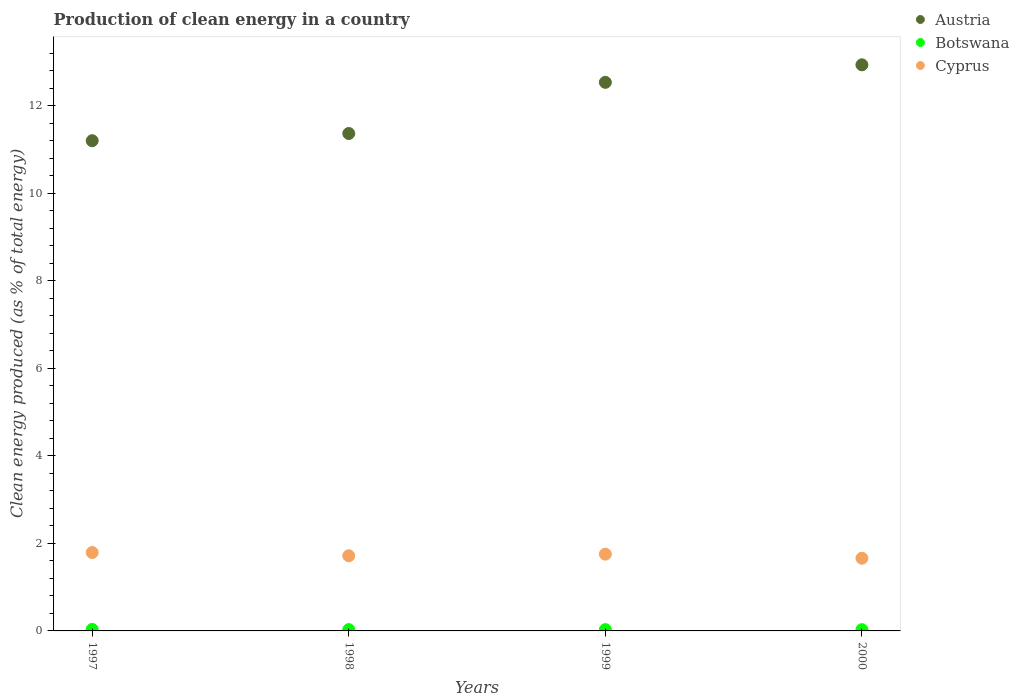How many different coloured dotlines are there?
Give a very brief answer. 3. What is the percentage of clean energy produced in Cyprus in 2000?
Offer a terse response. 1.66. Across all years, what is the maximum percentage of clean energy produced in Austria?
Keep it short and to the point. 12.93. Across all years, what is the minimum percentage of clean energy produced in Cyprus?
Your answer should be very brief. 1.66. In which year was the percentage of clean energy produced in Cyprus minimum?
Make the answer very short. 2000. What is the total percentage of clean energy produced in Botswana in the graph?
Your response must be concise. 0.12. What is the difference between the percentage of clean energy produced in Cyprus in 1998 and that in 2000?
Your answer should be compact. 0.06. What is the difference between the percentage of clean energy produced in Cyprus in 1998 and the percentage of clean energy produced in Austria in 2000?
Offer a terse response. -11.22. What is the average percentage of clean energy produced in Cyprus per year?
Your answer should be very brief. 1.73. In the year 1997, what is the difference between the percentage of clean energy produced in Botswana and percentage of clean energy produced in Austria?
Give a very brief answer. -11.17. In how many years, is the percentage of clean energy produced in Austria greater than 9.2 %?
Give a very brief answer. 4. What is the ratio of the percentage of clean energy produced in Cyprus in 1997 to that in 2000?
Offer a very short reply. 1.08. Is the percentage of clean energy produced in Botswana in 1997 less than that in 2000?
Offer a very short reply. No. Is the difference between the percentage of clean energy produced in Botswana in 1999 and 2000 greater than the difference between the percentage of clean energy produced in Austria in 1999 and 2000?
Your answer should be compact. Yes. What is the difference between the highest and the second highest percentage of clean energy produced in Botswana?
Provide a succinct answer. 0. What is the difference between the highest and the lowest percentage of clean energy produced in Cyprus?
Your answer should be compact. 0.13. Is the sum of the percentage of clean energy produced in Austria in 1998 and 2000 greater than the maximum percentage of clean energy produced in Botswana across all years?
Your response must be concise. Yes. Is it the case that in every year, the sum of the percentage of clean energy produced in Botswana and percentage of clean energy produced in Cyprus  is greater than the percentage of clean energy produced in Austria?
Your answer should be very brief. No. How many years are there in the graph?
Make the answer very short. 4. Where does the legend appear in the graph?
Provide a short and direct response. Top right. How are the legend labels stacked?
Make the answer very short. Vertical. What is the title of the graph?
Ensure brevity in your answer.  Production of clean energy in a country. Does "Niger" appear as one of the legend labels in the graph?
Your answer should be very brief. No. What is the label or title of the X-axis?
Your answer should be compact. Years. What is the label or title of the Y-axis?
Ensure brevity in your answer.  Clean energy produced (as % of total energy). What is the Clean energy produced (as % of total energy) in Austria in 1997?
Provide a succinct answer. 11.2. What is the Clean energy produced (as % of total energy) of Botswana in 1997?
Provide a short and direct response. 0.03. What is the Clean energy produced (as % of total energy) in Cyprus in 1997?
Offer a very short reply. 1.79. What is the Clean energy produced (as % of total energy) in Austria in 1998?
Provide a succinct answer. 11.36. What is the Clean energy produced (as % of total energy) in Botswana in 1998?
Provide a short and direct response. 0.03. What is the Clean energy produced (as % of total energy) in Cyprus in 1998?
Make the answer very short. 1.72. What is the Clean energy produced (as % of total energy) in Austria in 1999?
Your response must be concise. 12.53. What is the Clean energy produced (as % of total energy) in Botswana in 1999?
Keep it short and to the point. 0.03. What is the Clean energy produced (as % of total energy) in Cyprus in 1999?
Offer a terse response. 1.75. What is the Clean energy produced (as % of total energy) of Austria in 2000?
Give a very brief answer. 12.93. What is the Clean energy produced (as % of total energy) in Botswana in 2000?
Your response must be concise. 0.03. What is the Clean energy produced (as % of total energy) in Cyprus in 2000?
Ensure brevity in your answer.  1.66. Across all years, what is the maximum Clean energy produced (as % of total energy) of Austria?
Offer a very short reply. 12.93. Across all years, what is the maximum Clean energy produced (as % of total energy) of Botswana?
Provide a succinct answer. 0.03. Across all years, what is the maximum Clean energy produced (as % of total energy) of Cyprus?
Keep it short and to the point. 1.79. Across all years, what is the minimum Clean energy produced (as % of total energy) in Austria?
Your answer should be very brief. 11.2. Across all years, what is the minimum Clean energy produced (as % of total energy) in Botswana?
Keep it short and to the point. 0.03. Across all years, what is the minimum Clean energy produced (as % of total energy) of Cyprus?
Ensure brevity in your answer.  1.66. What is the total Clean energy produced (as % of total energy) of Austria in the graph?
Offer a very short reply. 48.03. What is the total Clean energy produced (as % of total energy) of Botswana in the graph?
Provide a succinct answer. 0.12. What is the total Clean energy produced (as % of total energy) in Cyprus in the graph?
Your response must be concise. 6.92. What is the difference between the Clean energy produced (as % of total energy) of Austria in 1997 and that in 1998?
Ensure brevity in your answer.  -0.16. What is the difference between the Clean energy produced (as % of total energy) in Botswana in 1997 and that in 1998?
Your response must be concise. 0. What is the difference between the Clean energy produced (as % of total energy) of Cyprus in 1997 and that in 1998?
Offer a terse response. 0.07. What is the difference between the Clean energy produced (as % of total energy) in Austria in 1997 and that in 1999?
Provide a short and direct response. -1.33. What is the difference between the Clean energy produced (as % of total energy) in Botswana in 1997 and that in 1999?
Keep it short and to the point. 0. What is the difference between the Clean energy produced (as % of total energy) in Cyprus in 1997 and that in 1999?
Your answer should be compact. 0.04. What is the difference between the Clean energy produced (as % of total energy) in Austria in 1997 and that in 2000?
Ensure brevity in your answer.  -1.73. What is the difference between the Clean energy produced (as % of total energy) in Botswana in 1997 and that in 2000?
Provide a succinct answer. 0.01. What is the difference between the Clean energy produced (as % of total energy) of Cyprus in 1997 and that in 2000?
Offer a very short reply. 0.13. What is the difference between the Clean energy produced (as % of total energy) of Austria in 1998 and that in 1999?
Offer a terse response. -1.17. What is the difference between the Clean energy produced (as % of total energy) in Botswana in 1998 and that in 1999?
Provide a succinct answer. 0. What is the difference between the Clean energy produced (as % of total energy) of Cyprus in 1998 and that in 1999?
Provide a short and direct response. -0.04. What is the difference between the Clean energy produced (as % of total energy) of Austria in 1998 and that in 2000?
Your answer should be very brief. -1.57. What is the difference between the Clean energy produced (as % of total energy) of Botswana in 1998 and that in 2000?
Offer a terse response. 0. What is the difference between the Clean energy produced (as % of total energy) in Cyprus in 1998 and that in 2000?
Provide a short and direct response. 0.06. What is the difference between the Clean energy produced (as % of total energy) in Austria in 1999 and that in 2000?
Offer a terse response. -0.4. What is the difference between the Clean energy produced (as % of total energy) of Botswana in 1999 and that in 2000?
Offer a very short reply. 0. What is the difference between the Clean energy produced (as % of total energy) in Cyprus in 1999 and that in 2000?
Keep it short and to the point. 0.09. What is the difference between the Clean energy produced (as % of total energy) in Austria in 1997 and the Clean energy produced (as % of total energy) in Botswana in 1998?
Offer a terse response. 11.17. What is the difference between the Clean energy produced (as % of total energy) in Austria in 1997 and the Clean energy produced (as % of total energy) in Cyprus in 1998?
Your response must be concise. 9.48. What is the difference between the Clean energy produced (as % of total energy) of Botswana in 1997 and the Clean energy produced (as % of total energy) of Cyprus in 1998?
Provide a short and direct response. -1.68. What is the difference between the Clean energy produced (as % of total energy) in Austria in 1997 and the Clean energy produced (as % of total energy) in Botswana in 1999?
Offer a very short reply. 11.17. What is the difference between the Clean energy produced (as % of total energy) of Austria in 1997 and the Clean energy produced (as % of total energy) of Cyprus in 1999?
Give a very brief answer. 9.45. What is the difference between the Clean energy produced (as % of total energy) of Botswana in 1997 and the Clean energy produced (as % of total energy) of Cyprus in 1999?
Give a very brief answer. -1.72. What is the difference between the Clean energy produced (as % of total energy) of Austria in 1997 and the Clean energy produced (as % of total energy) of Botswana in 2000?
Offer a very short reply. 11.17. What is the difference between the Clean energy produced (as % of total energy) in Austria in 1997 and the Clean energy produced (as % of total energy) in Cyprus in 2000?
Keep it short and to the point. 9.54. What is the difference between the Clean energy produced (as % of total energy) of Botswana in 1997 and the Clean energy produced (as % of total energy) of Cyprus in 2000?
Offer a terse response. -1.63. What is the difference between the Clean energy produced (as % of total energy) in Austria in 1998 and the Clean energy produced (as % of total energy) in Botswana in 1999?
Make the answer very short. 11.33. What is the difference between the Clean energy produced (as % of total energy) in Austria in 1998 and the Clean energy produced (as % of total energy) in Cyprus in 1999?
Offer a very short reply. 9.61. What is the difference between the Clean energy produced (as % of total energy) in Botswana in 1998 and the Clean energy produced (as % of total energy) in Cyprus in 1999?
Offer a terse response. -1.72. What is the difference between the Clean energy produced (as % of total energy) in Austria in 1998 and the Clean energy produced (as % of total energy) in Botswana in 2000?
Make the answer very short. 11.34. What is the difference between the Clean energy produced (as % of total energy) of Austria in 1998 and the Clean energy produced (as % of total energy) of Cyprus in 2000?
Make the answer very short. 9.7. What is the difference between the Clean energy produced (as % of total energy) in Botswana in 1998 and the Clean energy produced (as % of total energy) in Cyprus in 2000?
Your answer should be compact. -1.63. What is the difference between the Clean energy produced (as % of total energy) of Austria in 1999 and the Clean energy produced (as % of total energy) of Botswana in 2000?
Offer a terse response. 12.5. What is the difference between the Clean energy produced (as % of total energy) of Austria in 1999 and the Clean energy produced (as % of total energy) of Cyprus in 2000?
Provide a short and direct response. 10.87. What is the difference between the Clean energy produced (as % of total energy) in Botswana in 1999 and the Clean energy produced (as % of total energy) in Cyprus in 2000?
Make the answer very short. -1.63. What is the average Clean energy produced (as % of total energy) in Austria per year?
Provide a short and direct response. 12.01. What is the average Clean energy produced (as % of total energy) of Botswana per year?
Offer a very short reply. 0.03. What is the average Clean energy produced (as % of total energy) in Cyprus per year?
Make the answer very short. 1.73. In the year 1997, what is the difference between the Clean energy produced (as % of total energy) in Austria and Clean energy produced (as % of total energy) in Botswana?
Offer a terse response. 11.17. In the year 1997, what is the difference between the Clean energy produced (as % of total energy) in Austria and Clean energy produced (as % of total energy) in Cyprus?
Ensure brevity in your answer.  9.41. In the year 1997, what is the difference between the Clean energy produced (as % of total energy) of Botswana and Clean energy produced (as % of total energy) of Cyprus?
Give a very brief answer. -1.76. In the year 1998, what is the difference between the Clean energy produced (as % of total energy) of Austria and Clean energy produced (as % of total energy) of Botswana?
Ensure brevity in your answer.  11.33. In the year 1998, what is the difference between the Clean energy produced (as % of total energy) of Austria and Clean energy produced (as % of total energy) of Cyprus?
Give a very brief answer. 9.65. In the year 1998, what is the difference between the Clean energy produced (as % of total energy) in Botswana and Clean energy produced (as % of total energy) in Cyprus?
Provide a succinct answer. -1.69. In the year 1999, what is the difference between the Clean energy produced (as % of total energy) of Austria and Clean energy produced (as % of total energy) of Botswana?
Your answer should be compact. 12.5. In the year 1999, what is the difference between the Clean energy produced (as % of total energy) of Austria and Clean energy produced (as % of total energy) of Cyprus?
Offer a very short reply. 10.78. In the year 1999, what is the difference between the Clean energy produced (as % of total energy) of Botswana and Clean energy produced (as % of total energy) of Cyprus?
Your response must be concise. -1.72. In the year 2000, what is the difference between the Clean energy produced (as % of total energy) in Austria and Clean energy produced (as % of total energy) in Botswana?
Offer a very short reply. 12.9. In the year 2000, what is the difference between the Clean energy produced (as % of total energy) of Austria and Clean energy produced (as % of total energy) of Cyprus?
Offer a terse response. 11.27. In the year 2000, what is the difference between the Clean energy produced (as % of total energy) of Botswana and Clean energy produced (as % of total energy) of Cyprus?
Provide a short and direct response. -1.63. What is the ratio of the Clean energy produced (as % of total energy) in Austria in 1997 to that in 1998?
Offer a very short reply. 0.99. What is the ratio of the Clean energy produced (as % of total energy) in Botswana in 1997 to that in 1998?
Offer a very short reply. 1.13. What is the ratio of the Clean energy produced (as % of total energy) in Cyprus in 1997 to that in 1998?
Provide a short and direct response. 1.04. What is the ratio of the Clean energy produced (as % of total energy) of Austria in 1997 to that in 1999?
Offer a terse response. 0.89. What is the ratio of the Clean energy produced (as % of total energy) in Botswana in 1997 to that in 1999?
Your response must be concise. 1.17. What is the ratio of the Clean energy produced (as % of total energy) of Cyprus in 1997 to that in 1999?
Provide a succinct answer. 1.02. What is the ratio of the Clean energy produced (as % of total energy) in Austria in 1997 to that in 2000?
Offer a terse response. 0.87. What is the ratio of the Clean energy produced (as % of total energy) in Botswana in 1997 to that in 2000?
Provide a short and direct response. 1.2. What is the ratio of the Clean energy produced (as % of total energy) of Cyprus in 1997 to that in 2000?
Your response must be concise. 1.08. What is the ratio of the Clean energy produced (as % of total energy) in Austria in 1998 to that in 1999?
Offer a terse response. 0.91. What is the ratio of the Clean energy produced (as % of total energy) of Botswana in 1998 to that in 1999?
Offer a very short reply. 1.03. What is the ratio of the Clean energy produced (as % of total energy) in Cyprus in 1998 to that in 1999?
Your answer should be compact. 0.98. What is the ratio of the Clean energy produced (as % of total energy) in Austria in 1998 to that in 2000?
Give a very brief answer. 0.88. What is the ratio of the Clean energy produced (as % of total energy) in Botswana in 1998 to that in 2000?
Your answer should be compact. 1.07. What is the ratio of the Clean energy produced (as % of total energy) in Cyprus in 1998 to that in 2000?
Ensure brevity in your answer.  1.03. What is the ratio of the Clean energy produced (as % of total energy) of Botswana in 1999 to that in 2000?
Ensure brevity in your answer.  1.03. What is the ratio of the Clean energy produced (as % of total energy) of Cyprus in 1999 to that in 2000?
Offer a terse response. 1.06. What is the difference between the highest and the second highest Clean energy produced (as % of total energy) of Austria?
Give a very brief answer. 0.4. What is the difference between the highest and the second highest Clean energy produced (as % of total energy) of Botswana?
Give a very brief answer. 0. What is the difference between the highest and the second highest Clean energy produced (as % of total energy) of Cyprus?
Offer a very short reply. 0.04. What is the difference between the highest and the lowest Clean energy produced (as % of total energy) of Austria?
Keep it short and to the point. 1.73. What is the difference between the highest and the lowest Clean energy produced (as % of total energy) in Botswana?
Give a very brief answer. 0.01. What is the difference between the highest and the lowest Clean energy produced (as % of total energy) in Cyprus?
Keep it short and to the point. 0.13. 